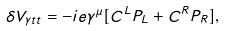<formula> <loc_0><loc_0><loc_500><loc_500>\delta V _ { \gamma t t } = - i e \gamma ^ { \mu } [ C ^ { L } P _ { L } + C ^ { R } P _ { R } ] ,</formula> 